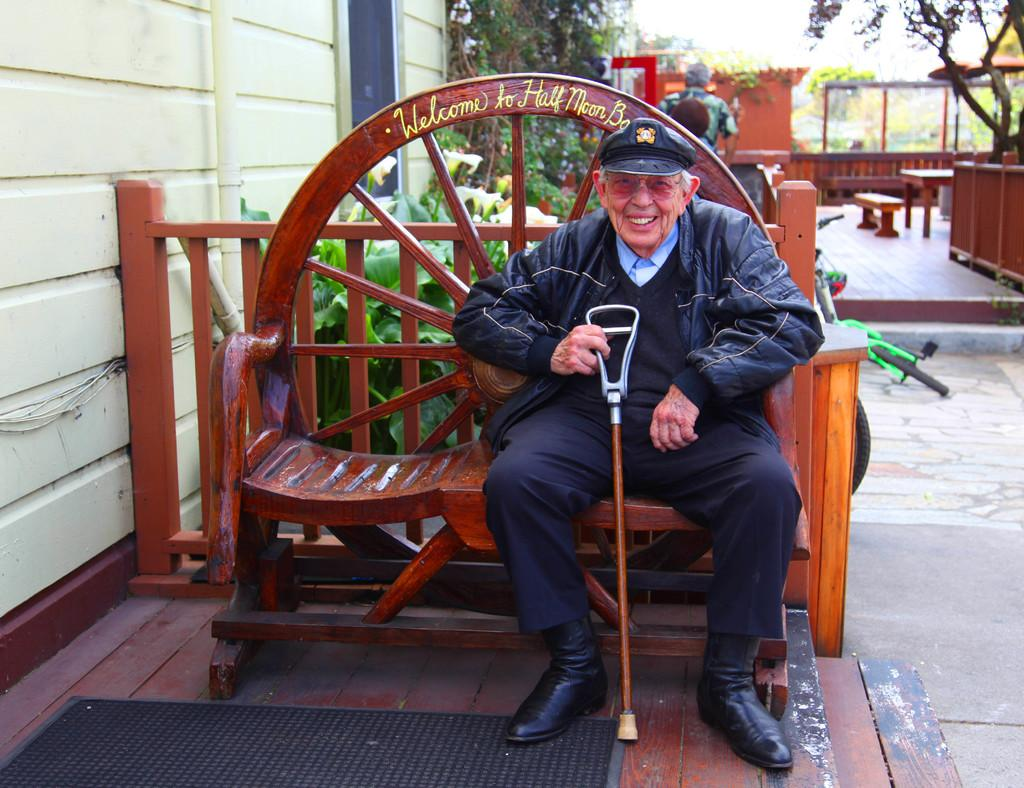What is the main subject of the image? The main subject of the image is an old man. What is the old man holding in his hand? The old man is holding a stick in his hand. What type of headwear is the old man wearing? The old man is wearing a cap. Where is the old man sitting in the image? The old man is sitting on a bench. What can be seen in the background of the image? Plants and trees are visible in the background of the image. What grade did the old man receive in the image? There is no indication of any grades or academic achievements in the image; it simply shows an old man sitting on a bench. How many beans are visible in the image? There are no beans present in the image. 